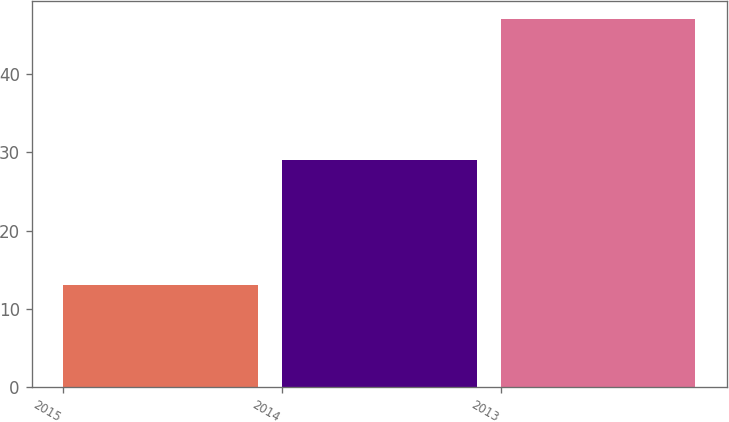<chart> <loc_0><loc_0><loc_500><loc_500><bar_chart><fcel>2015<fcel>2014<fcel>2013<nl><fcel>13<fcel>29<fcel>47<nl></chart> 